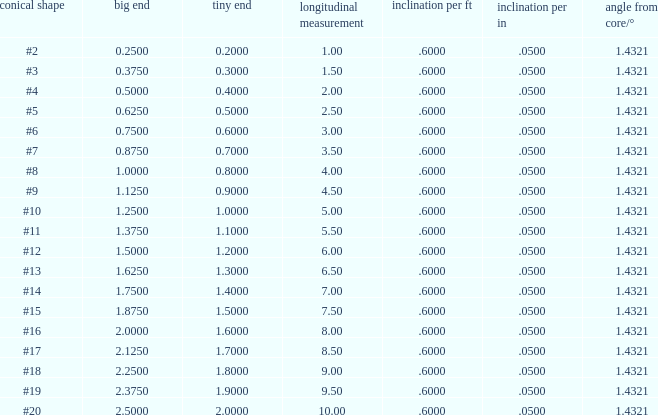Which Angle from center/° has a Taper/ft smaller than 0.6000000000000001? 19.0. 